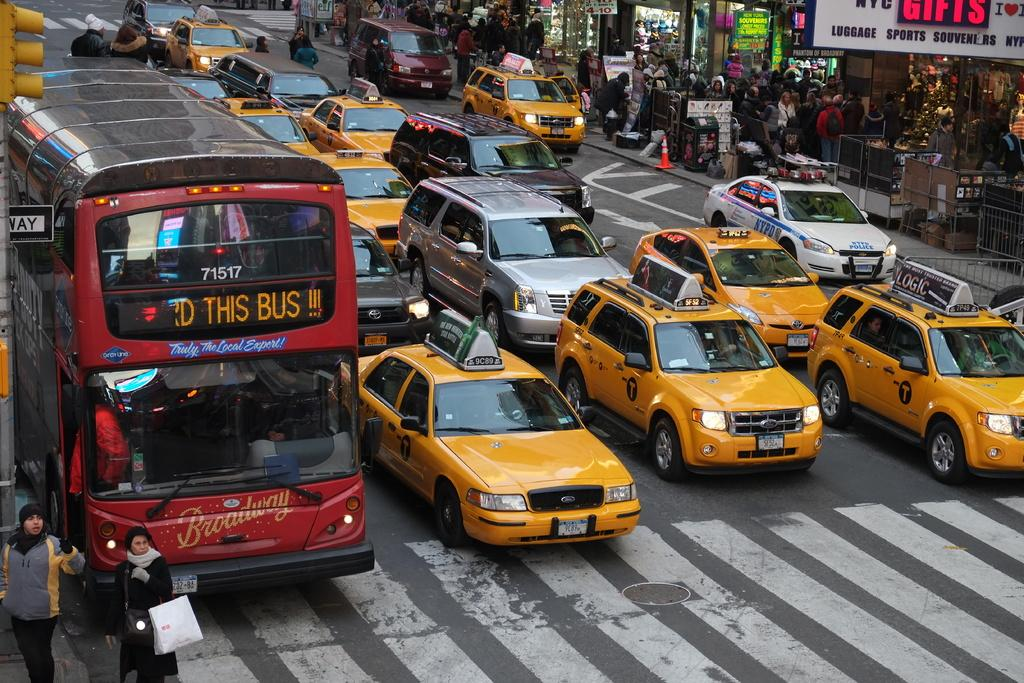<image>
Give a short and clear explanation of the subsequent image. A large, red bus that says Truly The Local Export on the front is in the furthest lane of a road full of Taxi cab's. 